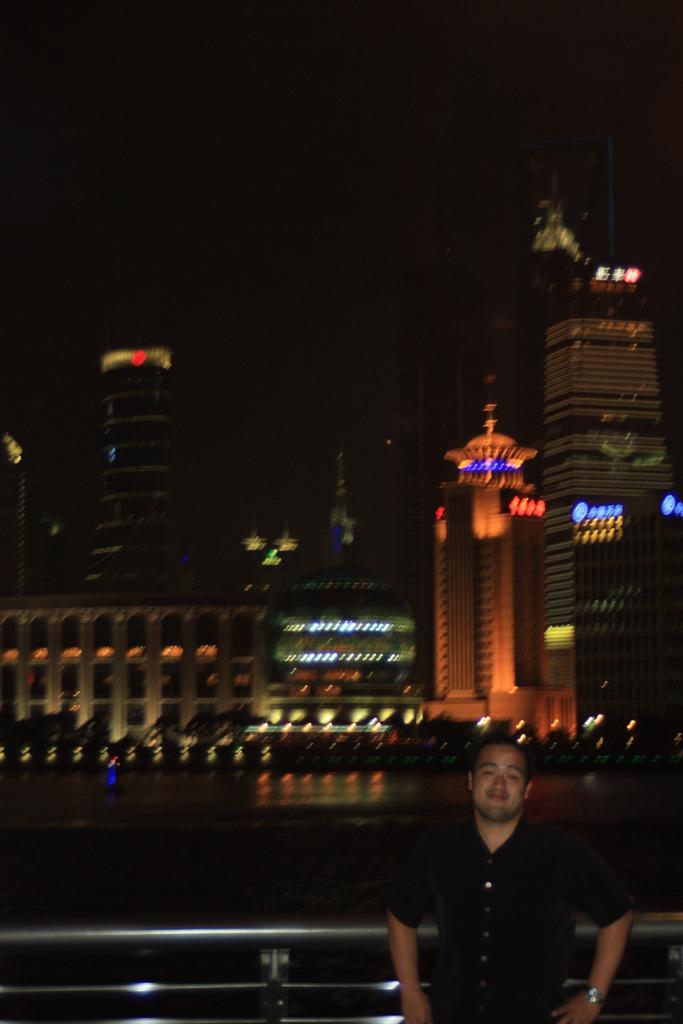What is the man in the image doing? The man is standing in the image and smiling. What can be seen behind the man? There is a fence behind the man. What is visible in the distance in the image? There are buildings and lights in the background of the image. How would you describe the overall lighting in the image? The image appears to be dark. What type of selection is available on the shelf behind the man? There is no shelf present in the image, and therefore no selection available. How does the man's hearing appear to be in the image? The image does not provide any information about the man's hearing, so it cannot be determined from the image. 